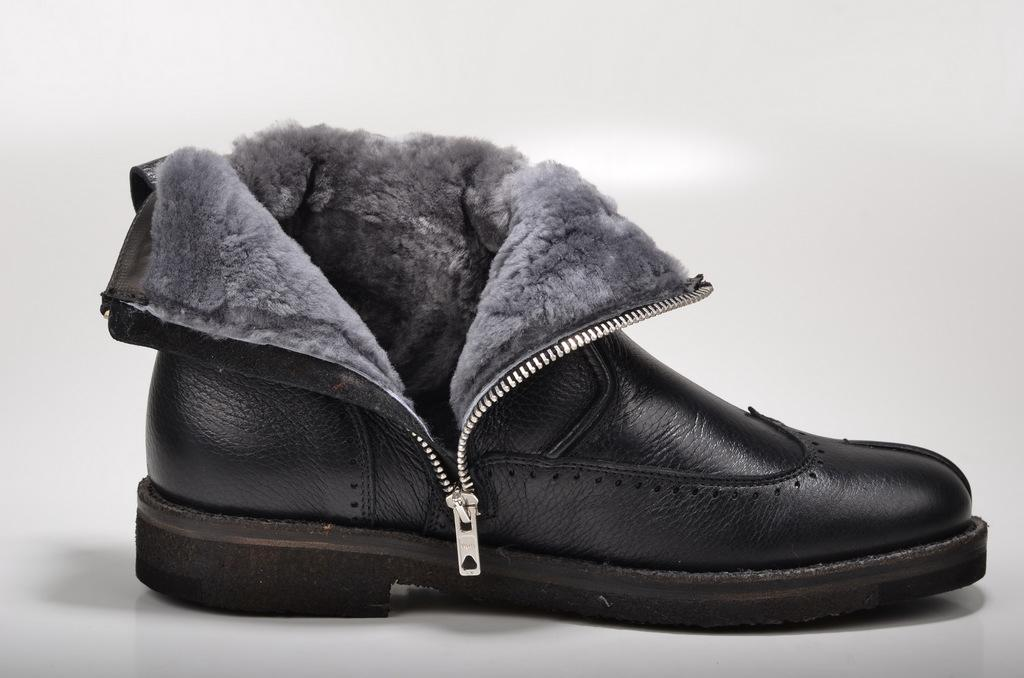What type of footwear is visible in the image? There is a black shoe in the image. What type of store can be seen in the image? There is no store present in the image; it only features a black shoe. What type of tool is used for cutting in the image? There are no tools or cutting activities depicted in the image; it only features a black shoe. 